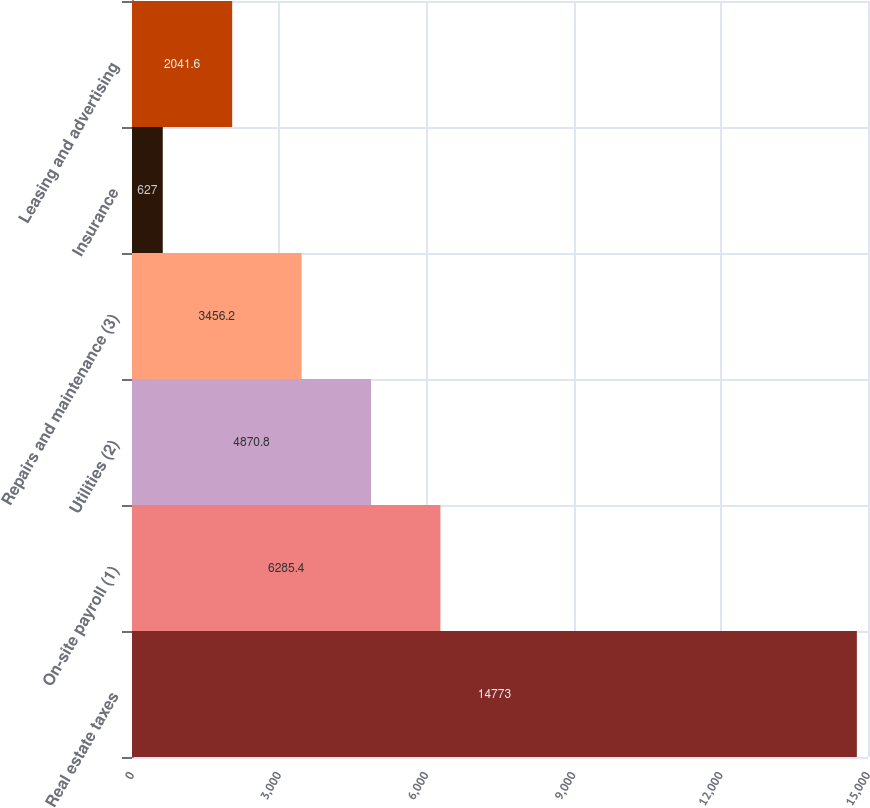<chart> <loc_0><loc_0><loc_500><loc_500><bar_chart><fcel>Real estate taxes<fcel>On-site payroll (1)<fcel>Utilities (2)<fcel>Repairs and maintenance (3)<fcel>Insurance<fcel>Leasing and advertising<nl><fcel>14773<fcel>6285.4<fcel>4870.8<fcel>3456.2<fcel>627<fcel>2041.6<nl></chart> 